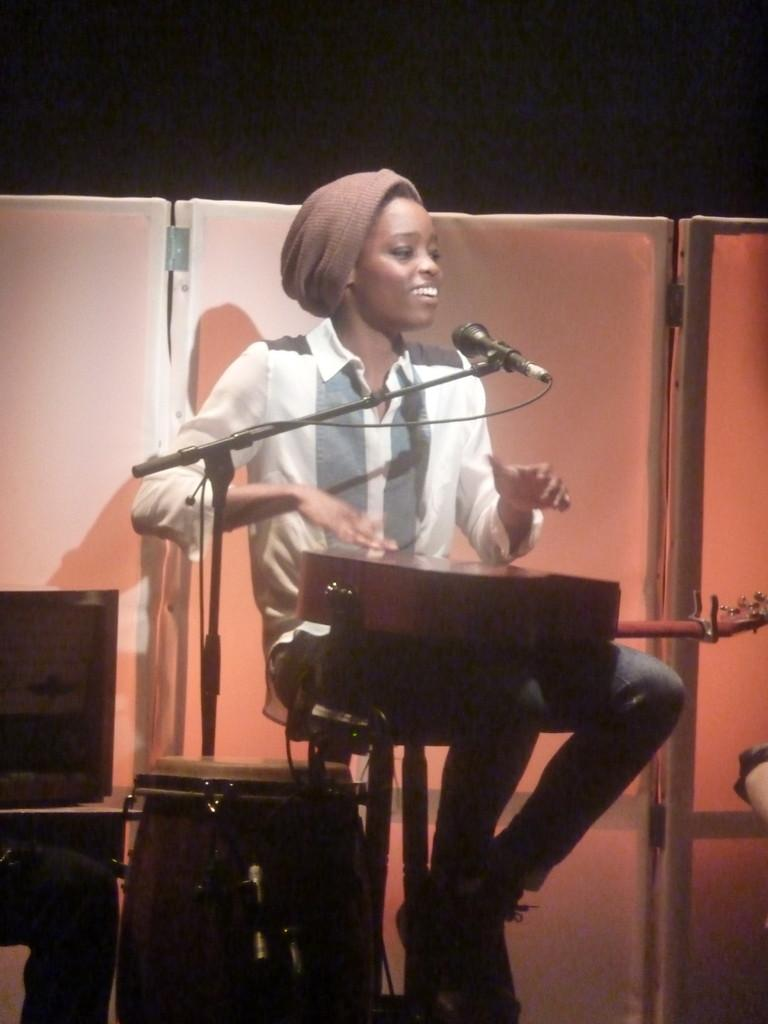Who is the main subject in the image? There is a lady in the image. What is the lady doing in the image? The lady is singing on a mic and tapping on a guitar. What type of clouds can be seen in the background of the image? There is no background or clouds visible in the image; it only features the lady singing and tapping on a guitar. 